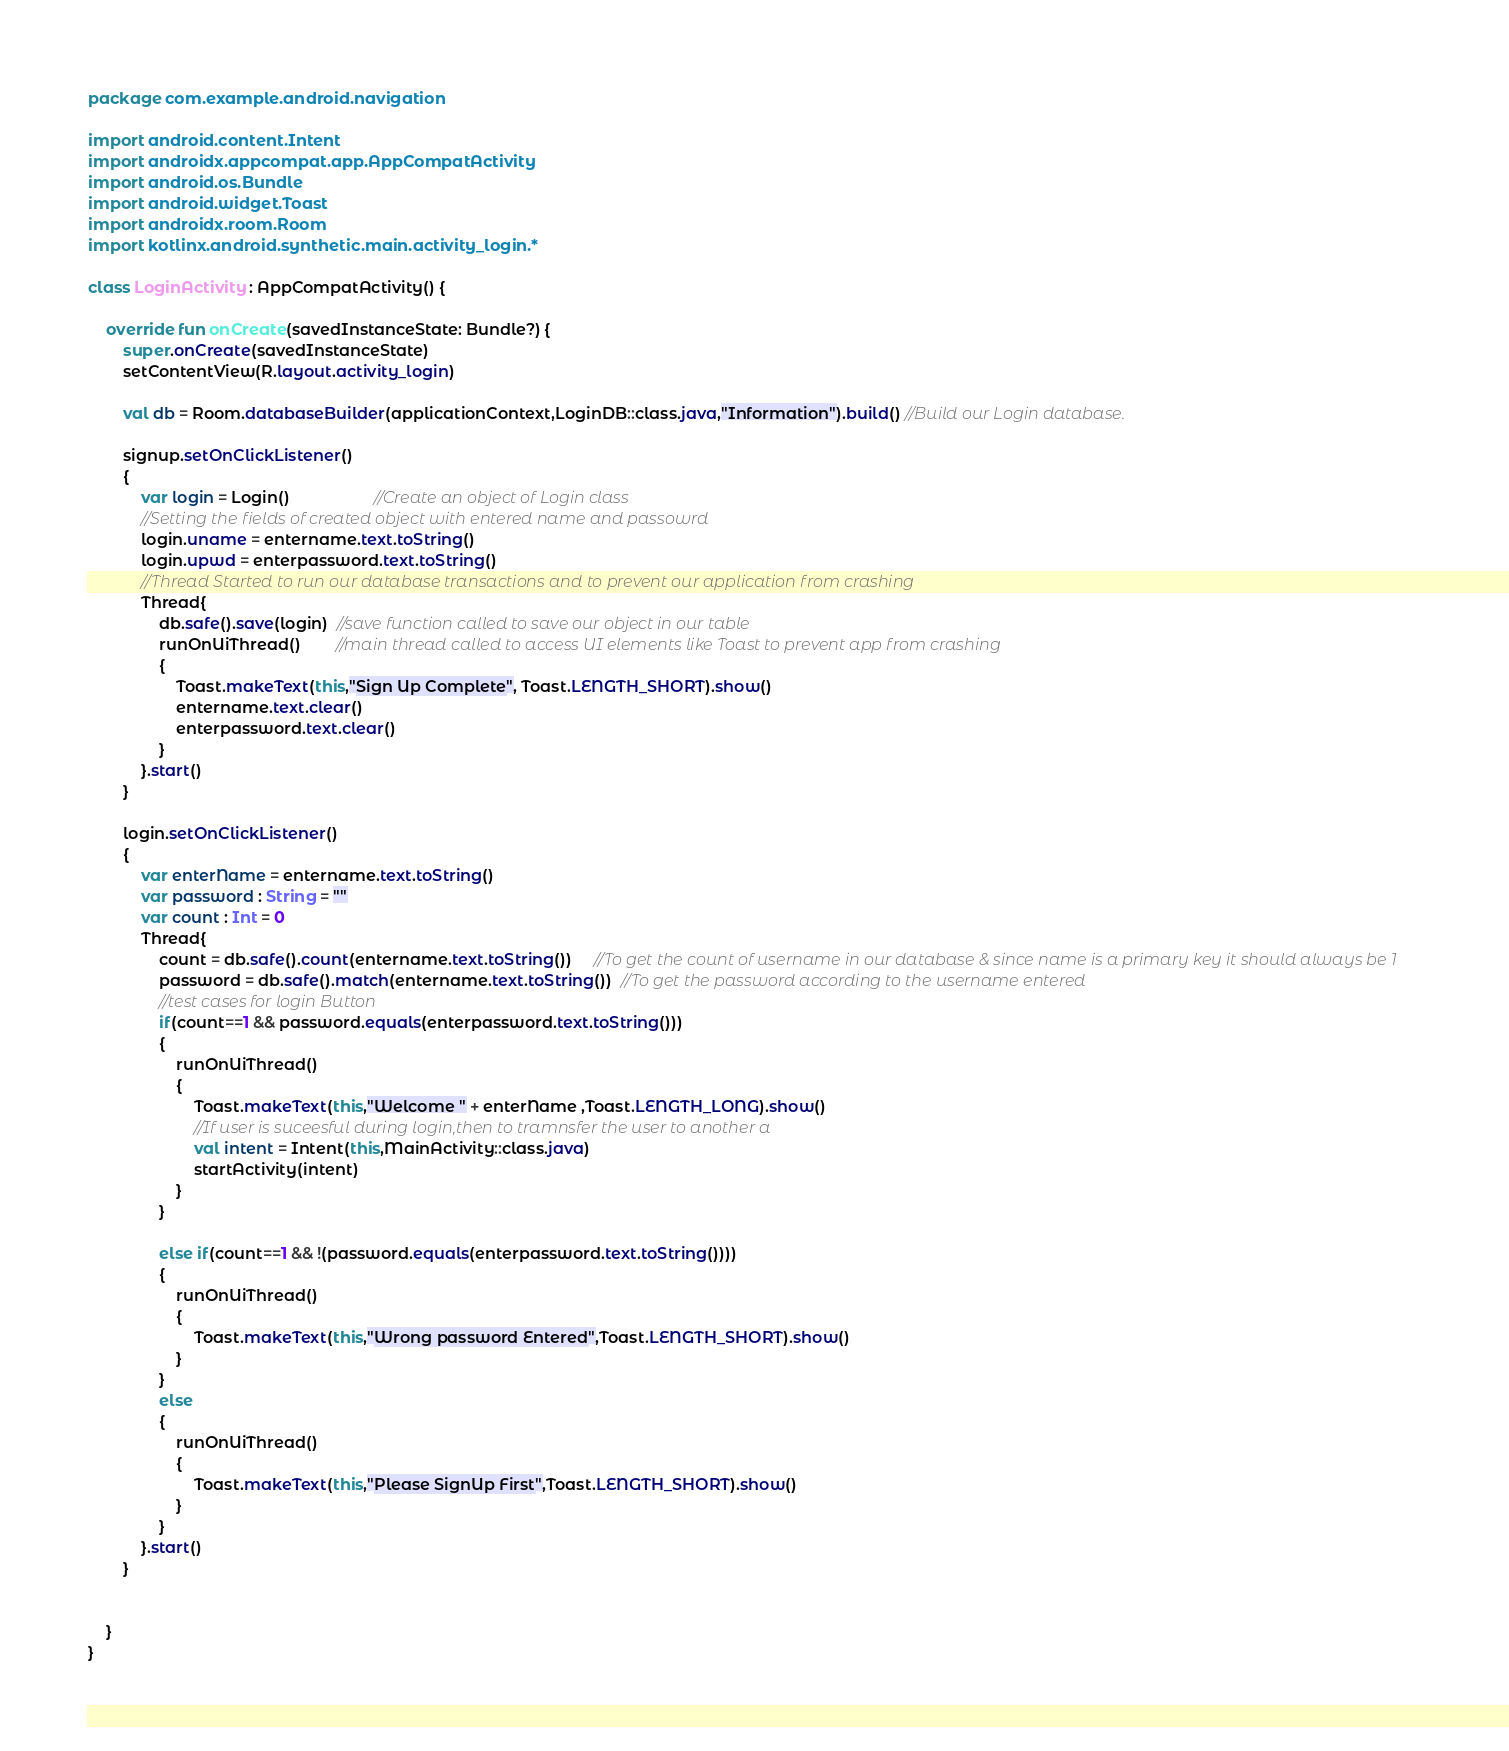Convert code to text. <code><loc_0><loc_0><loc_500><loc_500><_Kotlin_>package com.example.android.navigation

import android.content.Intent
import androidx.appcompat.app.AppCompatActivity
import android.os.Bundle
import android.widget.Toast
import androidx.room.Room
import kotlinx.android.synthetic.main.activity_login.*

class LoginActivity : AppCompatActivity() {

    override fun onCreate(savedInstanceState: Bundle?) {
        super.onCreate(savedInstanceState)
        setContentView(R.layout.activity_login)

        val db = Room.databaseBuilder(applicationContext,LoginDB::class.java,"Information").build() //Build our Login database.

        signup.setOnClickListener()
        {
            var login = Login()                   //Create an object of Login class
            //Setting the fields of created object with entered name and passowrd
            login.uname = entername.text.toString()
            login.upwd = enterpassword.text.toString()
            //Thread Started to run our database transactions and to prevent our application from crashing
            Thread{
                db.safe().save(login)  //save function called to save our object in our table
                runOnUiThread()        //main thread called to access UI elements like Toast to prevent app from crashing
                {
                    Toast.makeText(this,"Sign Up Complete", Toast.LENGTH_SHORT).show()
                    entername.text.clear()
                    enterpassword.text.clear()
                }
            }.start()
        }

        login.setOnClickListener()
        {
            var enterName = entername.text.toString()
            var password : String = ""
            var count : Int = 0
            Thread{
                count = db.safe().count(entername.text.toString())     //To get the count of username in our database & since name is a primary key it should always be 1
                password = db.safe().match(entername.text.toString())  //To get the password according to the username entered
                //test cases for login Button
                if(count==1 && password.equals(enterpassword.text.toString()))
                {
                    runOnUiThread()
                    {
                        Toast.makeText(this,"Welcome " + enterName ,Toast.LENGTH_LONG).show()
                        //If user is suceesful during login,then to tramnsfer the user to another a
                        val intent = Intent(this,MainActivity::class.java)
                        startActivity(intent)
                    }
                }

                else if(count==1 && !(password.equals(enterpassword.text.toString())))
                {
                    runOnUiThread()
                    {
                        Toast.makeText(this,"Wrong password Entered",Toast.LENGTH_SHORT).show()
                    }
                }
                else
                {
                    runOnUiThread()
                    {
                        Toast.makeText(this,"Please SignUp First",Toast.LENGTH_SHORT).show()
                    }
                }
            }.start()
        }


    }
}
</code> 